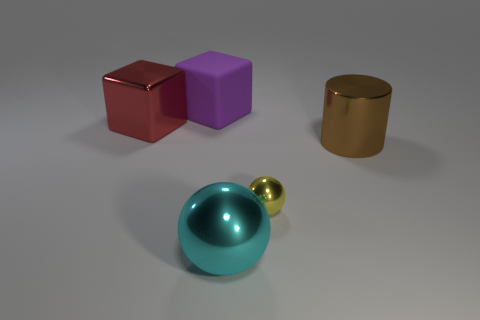What material is the big thing that is left of the large cube that is behind the red metal block made of?
Ensure brevity in your answer.  Metal. How many other objects are there of the same shape as the big brown metallic thing?
Your answer should be compact. 0. Is the shape of the small metallic thing on the right side of the red block the same as the metallic object right of the yellow object?
Your response must be concise. No. Is there any other thing that has the same material as the tiny yellow ball?
Your answer should be very brief. Yes. What material is the small object?
Give a very brief answer. Metal. There is a object that is behind the large red metallic object; what material is it?
Offer a terse response. Rubber. Is there anything else that has the same color as the big metallic cube?
Offer a terse response. No. What is the size of the cyan ball that is made of the same material as the big red object?
Make the answer very short. Large. How many tiny objects are either cyan rubber objects or shiny cylinders?
Provide a short and direct response. 0. There is a metal thing right of the metallic sphere that is right of the large metallic thing that is in front of the brown thing; how big is it?
Keep it short and to the point. Large. 